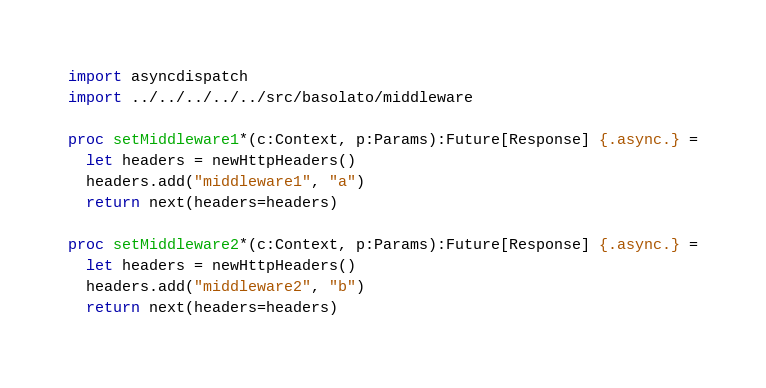<code> <loc_0><loc_0><loc_500><loc_500><_Nim_>import asyncdispatch
import ../../../../../src/basolato/middleware

proc setMiddleware1*(c:Context, p:Params):Future[Response] {.async.} =
  let headers = newHttpHeaders()
  headers.add("middleware1", "a")
  return next(headers=headers)

proc setMiddleware2*(c:Context, p:Params):Future[Response] {.async.} =
  let headers = newHttpHeaders()
  headers.add("middleware2", "b")
  return next(headers=headers)
</code> 